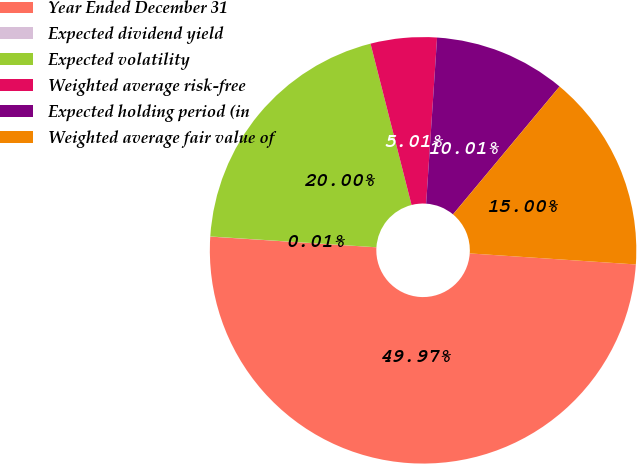Convert chart to OTSL. <chart><loc_0><loc_0><loc_500><loc_500><pie_chart><fcel>Year Ended December 31<fcel>Expected dividend yield<fcel>Expected volatility<fcel>Weighted average risk-free<fcel>Expected holding period (in<fcel>Weighted average fair value of<nl><fcel>49.97%<fcel>0.01%<fcel>20.0%<fcel>5.01%<fcel>10.01%<fcel>15.0%<nl></chart> 